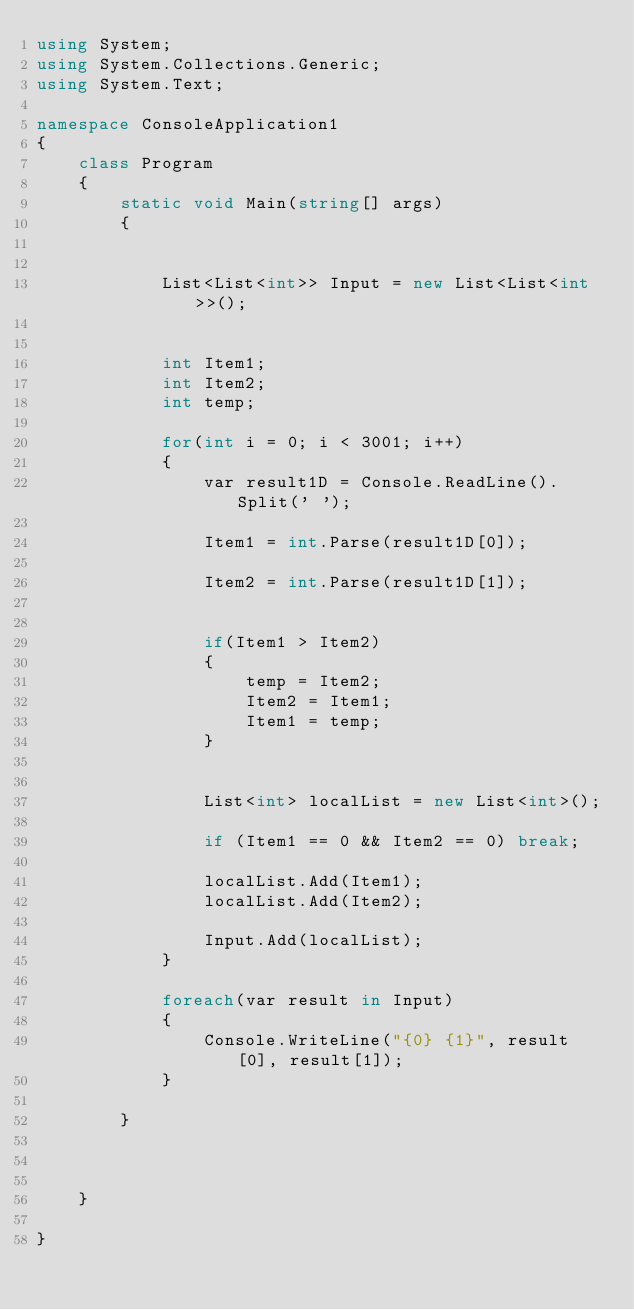Convert code to text. <code><loc_0><loc_0><loc_500><loc_500><_C#_>using System;
using System.Collections.Generic;
using System.Text;

namespace ConsoleApplication1
{
    class Program
    {
        static void Main(string[] args)
        {
            

            List<List<int>> Input = new List<List<int>>();


            int Item1;
            int Item2;
            int temp;

            for(int i = 0; i < 3001; i++)
            {
                var result1D = Console.ReadLine().Split(' ');

                Item1 = int.Parse(result1D[0]);

                Item2 = int.Parse(result1D[1]);


                if(Item1 > Item2)
                {
                    temp = Item2;
                    Item2 = Item1;
                    Item1 = temp;
                }


                List<int> localList = new List<int>();

                if (Item1 == 0 && Item2 == 0) break;

                localList.Add(Item1);
                localList.Add(Item2);

                Input.Add(localList);
            }

            foreach(var result in Input)
            {
                Console.WriteLine("{0} {1}", result[0], result[1]);
            }

        }



    }

}</code> 